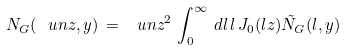<formula> <loc_0><loc_0><loc_500><loc_500>N _ { G } ( \ u n z , y ) \, = \, \ u n z ^ { 2 } \, \int _ { 0 } ^ { \infty } \, d l \, l \, J _ { 0 } ( l z ) \tilde { N } _ { G } ( l , y )</formula> 